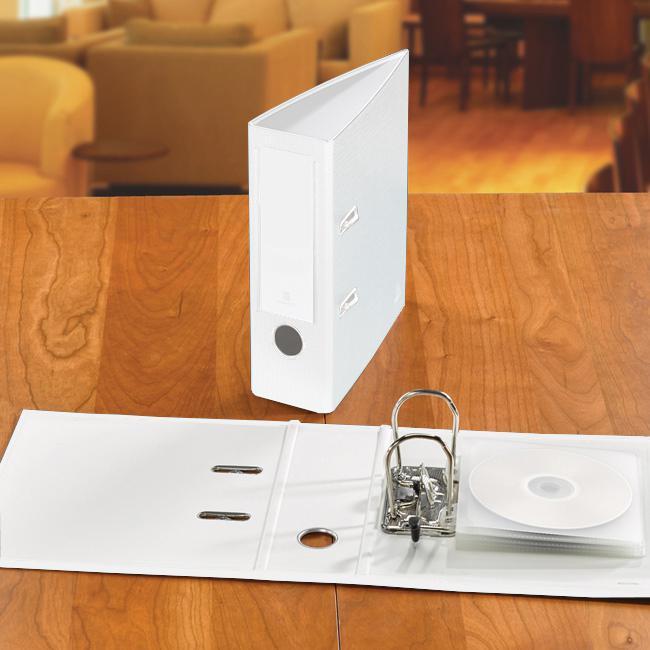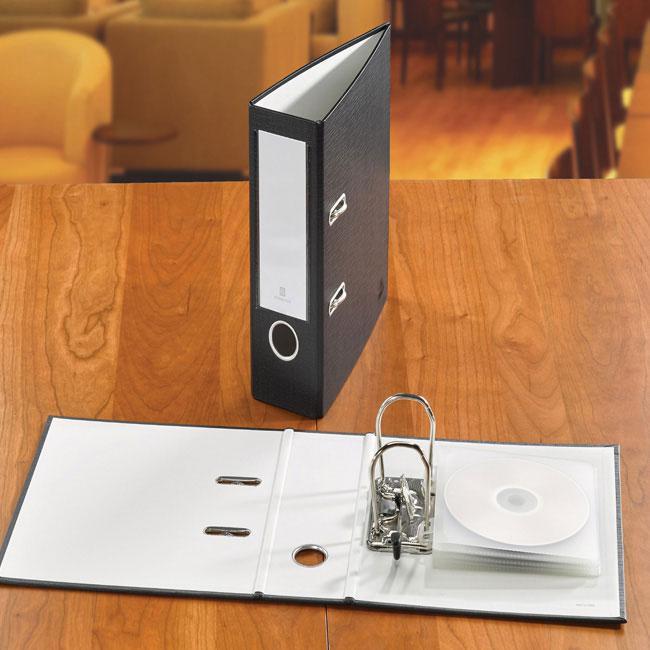The first image is the image on the left, the second image is the image on the right. Considering the images on both sides, is "There are two black binders on a wooden surface." valid? Answer yes or no. No. The first image is the image on the left, the second image is the image on the right. Analyze the images presented: Is the assertion "An image includes a black upright binder with a black circle below a white rectangle on its end." valid? Answer yes or no. Yes. 